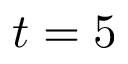Convert formula to latex. <formula><loc_0><loc_0><loc_500><loc_500>t = 5</formula> 